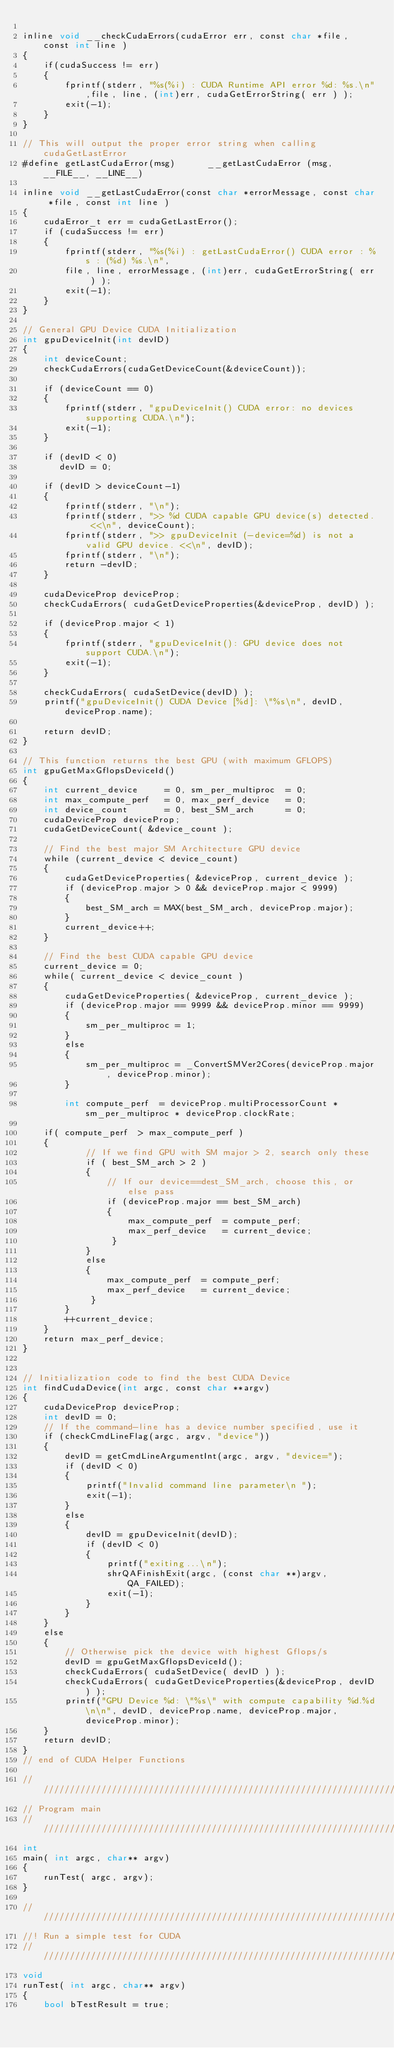Convert code to text. <code><loc_0><loc_0><loc_500><loc_500><_Cuda_>
inline void __checkCudaErrors(cudaError err, const char *file, const int line )
{
    if(cudaSuccess != err)
    {
        fprintf(stderr, "%s(%i) : CUDA Runtime API error %d: %s.\n",file, line, (int)err, cudaGetErrorString( err ) );
        exit(-1);        
    }
}

// This will output the proper error string when calling cudaGetLastError
#define getLastCudaError(msg)      __getLastCudaError (msg, __FILE__, __LINE__)

inline void __getLastCudaError(const char *errorMessage, const char *file, const int line )
{
    cudaError_t err = cudaGetLastError();
    if (cudaSuccess != err)
    {
        fprintf(stderr, "%s(%i) : getLastCudaError() CUDA error : %s : (%d) %s.\n",
        file, line, errorMessage, (int)err, cudaGetErrorString( err ) );
        exit(-1);
    }
}

// General GPU Device CUDA Initialization
int gpuDeviceInit(int devID)
{
    int deviceCount;
    checkCudaErrors(cudaGetDeviceCount(&deviceCount));

    if (deviceCount == 0)
    {
        fprintf(stderr, "gpuDeviceInit() CUDA error: no devices supporting CUDA.\n");
        exit(-1);
    }

    if (devID < 0)
       devID = 0;
        
    if (devID > deviceCount-1)
    {
        fprintf(stderr, "\n");
        fprintf(stderr, ">> %d CUDA capable GPU device(s) detected. <<\n", deviceCount);
        fprintf(stderr, ">> gpuDeviceInit (-device=%d) is not a valid GPU device. <<\n", devID);
        fprintf(stderr, "\n");
        return -devID;
    }

    cudaDeviceProp deviceProp;
    checkCudaErrors( cudaGetDeviceProperties(&deviceProp, devID) );

    if (deviceProp.major < 1)
    {
        fprintf(stderr, "gpuDeviceInit(): GPU device does not support CUDA.\n");
        exit(-1);                                                  
    }
    
    checkCudaErrors( cudaSetDevice(devID) );
    printf("gpuDeviceInit() CUDA Device [%d]: \"%s\n", devID, deviceProp.name);

    return devID;
}

// This function returns the best GPU (with maximum GFLOPS)
int gpuGetMaxGflopsDeviceId()
{
    int current_device     = 0, sm_per_multiproc  = 0;
    int max_compute_perf   = 0, max_perf_device   = 0;
    int device_count       = 0, best_SM_arch      = 0;
    cudaDeviceProp deviceProp;
    cudaGetDeviceCount( &device_count );
    
    // Find the best major SM Architecture GPU device
    while (current_device < device_count)
    {
        cudaGetDeviceProperties( &deviceProp, current_device );
        if (deviceProp.major > 0 && deviceProp.major < 9999)
        {
            best_SM_arch = MAX(best_SM_arch, deviceProp.major);
        }
        current_device++;
    }

    // Find the best CUDA capable GPU device
    current_device = 0;
    while( current_device < device_count )
    {
        cudaGetDeviceProperties( &deviceProp, current_device );
        if (deviceProp.major == 9999 && deviceProp.minor == 9999)
        {
            sm_per_multiproc = 1;
        }
        else
        {
            sm_per_multiproc = _ConvertSMVer2Cores(deviceProp.major, deviceProp.minor);
        }
        
        int compute_perf  = deviceProp.multiProcessorCount * sm_per_multiproc * deviceProp.clockRate;
        
    if( compute_perf  > max_compute_perf )
    {
            // If we find GPU with SM major > 2, search only these
            if ( best_SM_arch > 2 )
            {
                // If our device==dest_SM_arch, choose this, or else pass
                if (deviceProp.major == best_SM_arch)
                {
                    max_compute_perf  = compute_perf;
                    max_perf_device   = current_device;
                 }
            }
            else
            {
                max_compute_perf  = compute_perf;
                max_perf_device   = current_device;
             }
        }
        ++current_device;
    }
    return max_perf_device;
}


// Initialization code to find the best CUDA Device
int findCudaDevice(int argc, const char **argv)
{
    cudaDeviceProp deviceProp;
    int devID = 0;
    // If the command-line has a device number specified, use it
    if (checkCmdLineFlag(argc, argv, "device"))
    {
        devID = getCmdLineArgumentInt(argc, argv, "device=");
        if (devID < 0)
        {
            printf("Invalid command line parameter\n ");
            exit(-1);
        }
        else
        {
            devID = gpuDeviceInit(devID);
            if (devID < 0)
            {
                printf("exiting...\n");
                shrQAFinishExit(argc, (const char **)argv, QA_FAILED);
                exit(-1);
            }
        }
    }
    else
    {
        // Otherwise pick the device with highest Gflops/s
        devID = gpuGetMaxGflopsDeviceId();
        checkCudaErrors( cudaSetDevice( devID ) );
        checkCudaErrors( cudaGetDeviceProperties(&deviceProp, devID) );
        printf("GPU Device %d: \"%s\" with compute capability %d.%d\n\n", devID, deviceProp.name, deviceProp.major, deviceProp.minor);
    }
    return devID;
}
// end of CUDA Helper Functions

////////////////////////////////////////////////////////////////////////////////
// Program main
////////////////////////////////////////////////////////////////////////////////
int
main( int argc, char** argv) 
{
    runTest( argc, argv);
}

////////////////////////////////////////////////////////////////////////////////
//! Run a simple test for CUDA
////////////////////////////////////////////////////////////////////////////////
void
runTest( int argc, char** argv) 
{
    bool bTestResult = true;</code> 